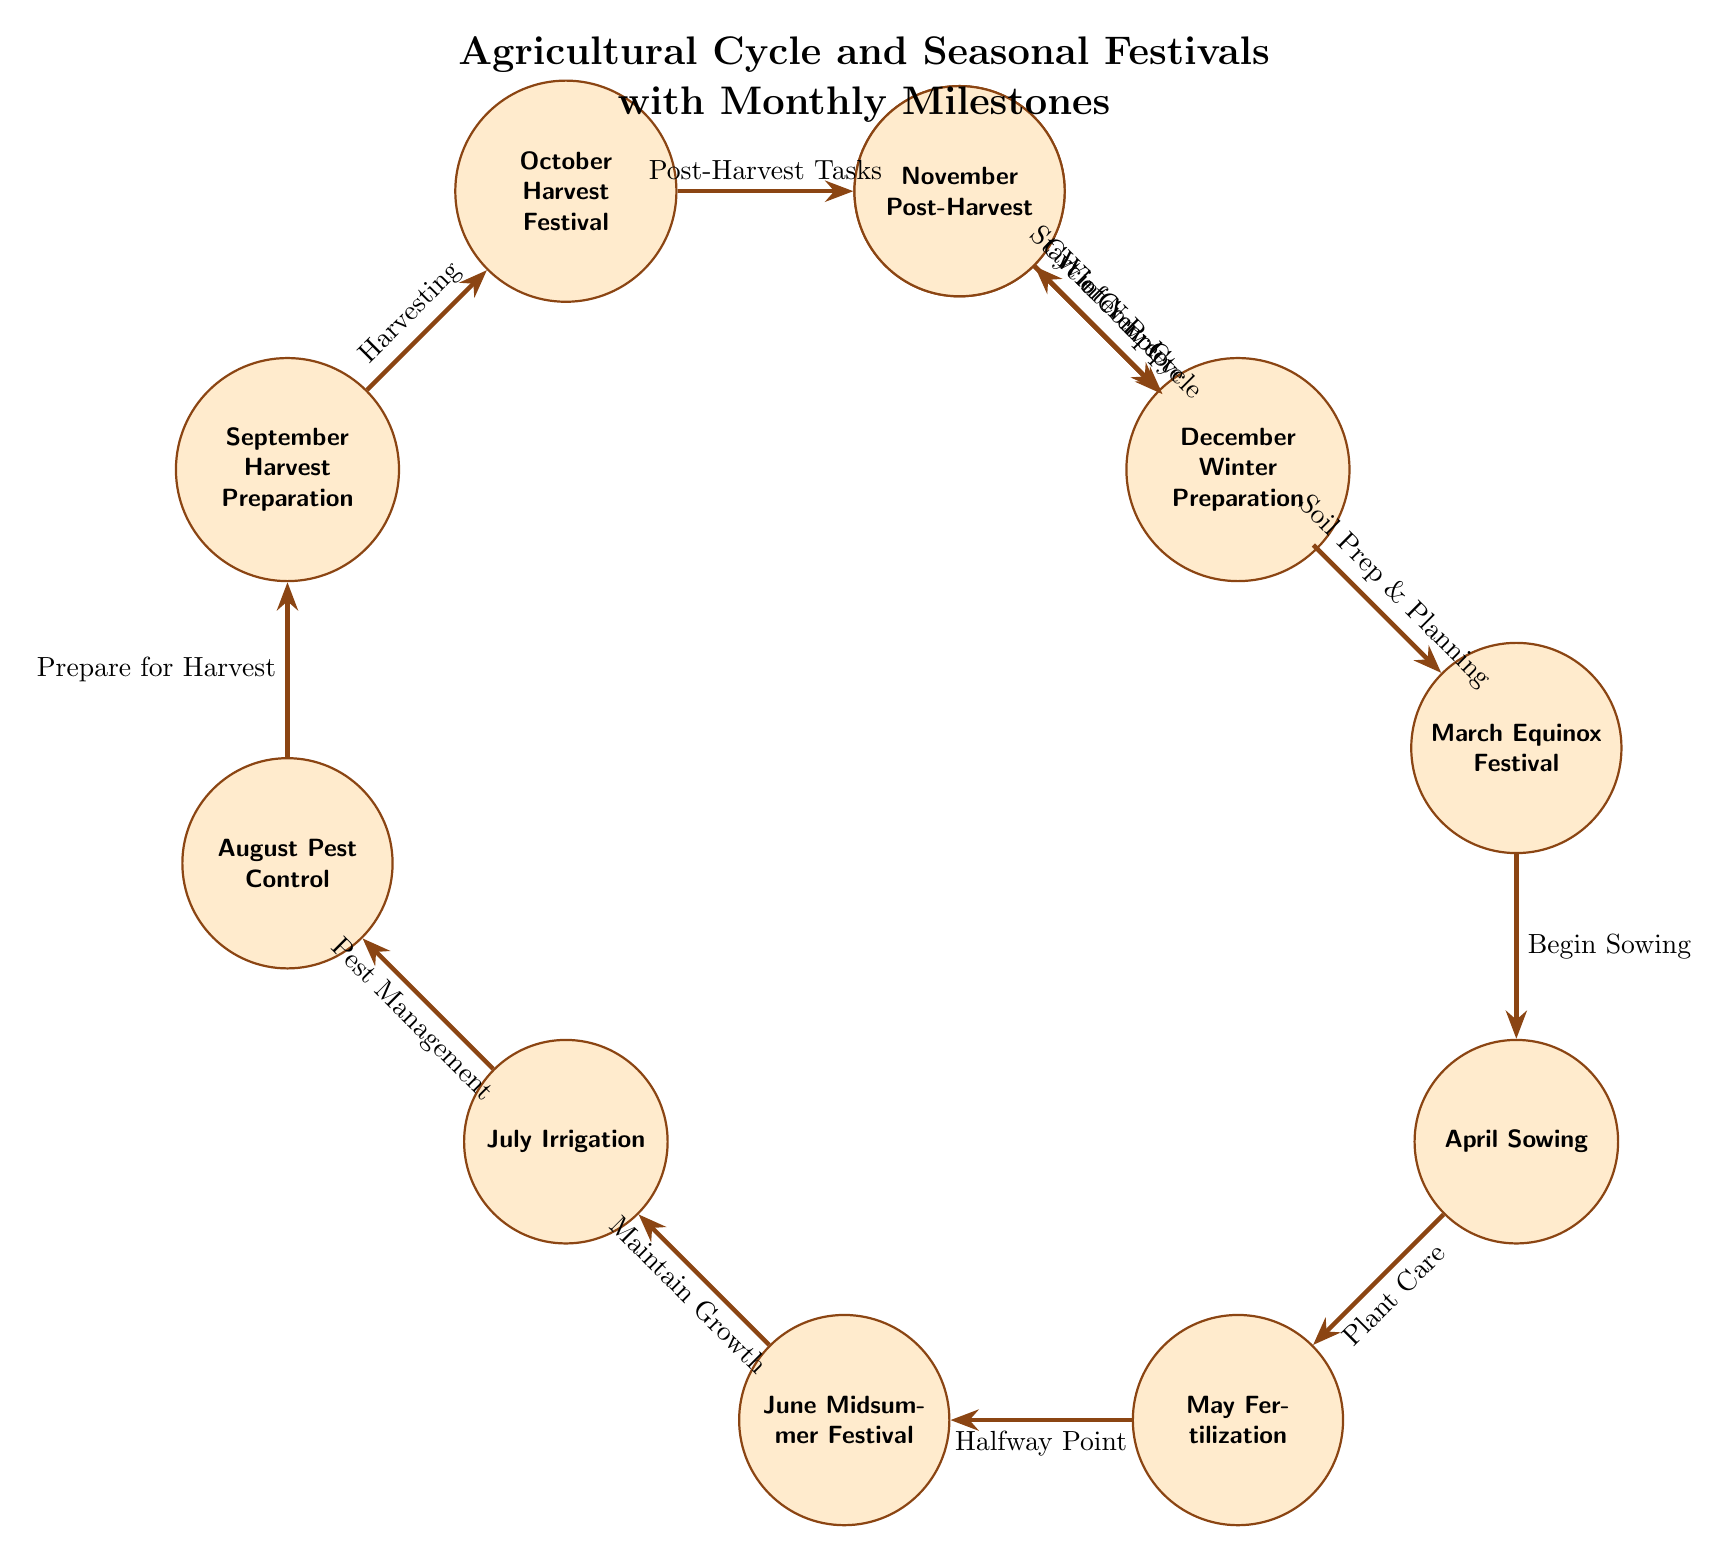What is the main activity in April? The diagram indicates that the main activity in April is "Sowing". This is clearly labeled as the node corresponding to the month of April.
Answer: Sowing How many seasonal festivals are depicted in the diagram? By counting the specific nodes labeled as festivals in the diagram—March Equinox Festival, June Midsummer Festival, and October Harvest Festival—we can determine that there are three seasonal festivals present.
Answer: 3 What connects January to February? The relationship from January to February is established by the edge labeled "Start of New Cycle". This shows the progression typical in the agricultural cycle from the Winter Solstice to preparation.
Answer: Start of New Cycle What is the month immediately after the Pest Control activity? The diagram shows that Pest Control takes place in August, and the next node in sequence is September, which focuses on Harvest Preparation.
Answer: September What activity occurs in November? According to the diagram, the activity designated for November is "Post-Harvest". This is clearly indicated as the node for that month in the agricultural cycle.
Answer: Post-Harvest Which month is associated with maintaining growth? The diagram illustrates that "Maintain Growth" corresponds to the month of July, as indicated by the edge leading from the Midsummer Festival to the Irrigation activity.
Answer: July What is the final step before starting the new agricultural cycle? The diagram indicates that the final step before returning to the beginning of the cycle (January) is "Winter Preparation," which is indicated as the activity in December.
Answer: Winter Preparation What edge connects October to November? The edge connecting October to November is labeled "Post-Harvest Tasks," which shows the flow of activities following the Harvest Festival.
Answer: Post-Harvest Tasks Which month is dedicated to irrigation? According to the diagram, irrigation is the main focus in July, as it is labeled directly in the corresponding node for that month.
Answer: July 